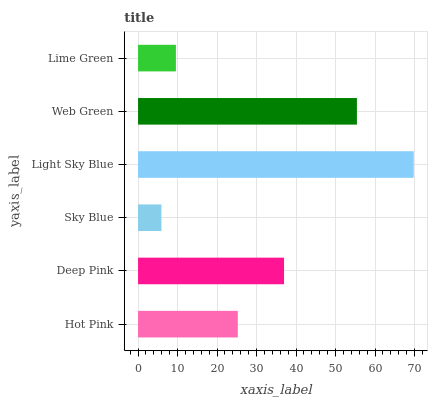Is Sky Blue the minimum?
Answer yes or no. Yes. Is Light Sky Blue the maximum?
Answer yes or no. Yes. Is Deep Pink the minimum?
Answer yes or no. No. Is Deep Pink the maximum?
Answer yes or no. No. Is Deep Pink greater than Hot Pink?
Answer yes or no. Yes. Is Hot Pink less than Deep Pink?
Answer yes or no. Yes. Is Hot Pink greater than Deep Pink?
Answer yes or no. No. Is Deep Pink less than Hot Pink?
Answer yes or no. No. Is Deep Pink the high median?
Answer yes or no. Yes. Is Hot Pink the low median?
Answer yes or no. Yes. Is Light Sky Blue the high median?
Answer yes or no. No. Is Deep Pink the low median?
Answer yes or no. No. 